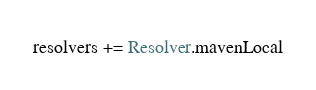<code> <loc_0><loc_0><loc_500><loc_500><_Scala_>resolvers += Resolver.mavenLocal
</code> 